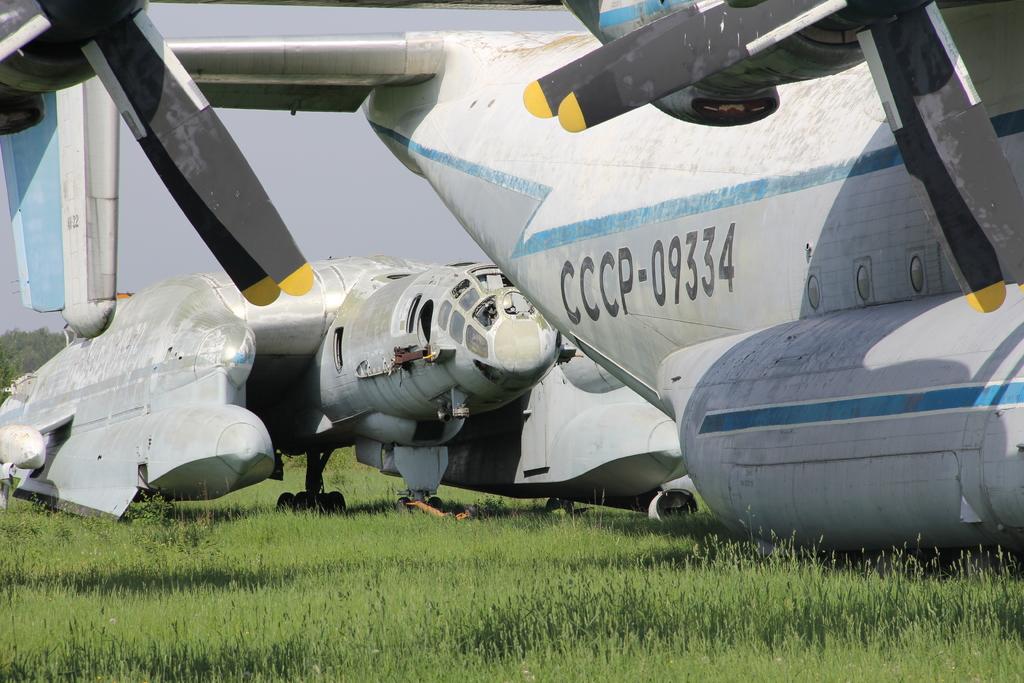What is the plane number?
Your answer should be very brief. Cccp-09334. 